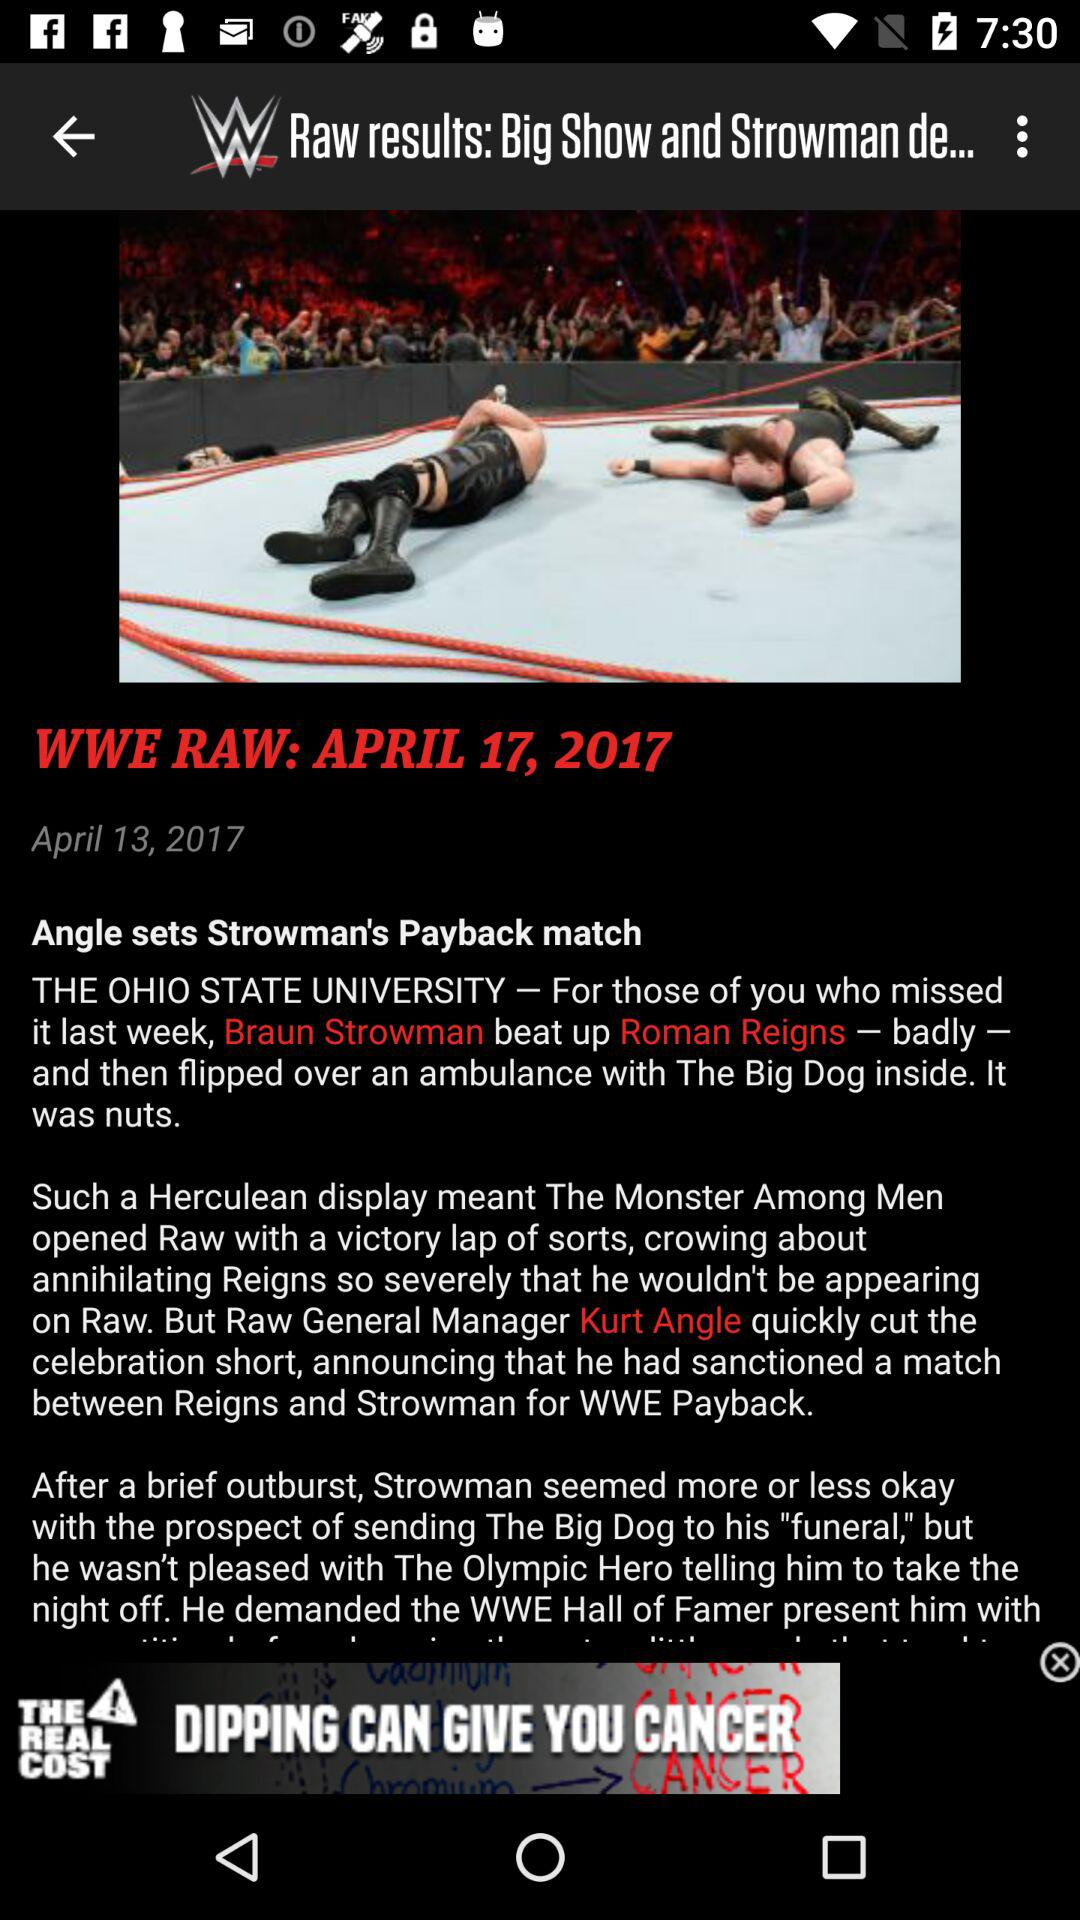Between whom is the WWE Payback match scheduled? The WWE Payback match is scheduled between Reigns and Strowman. 